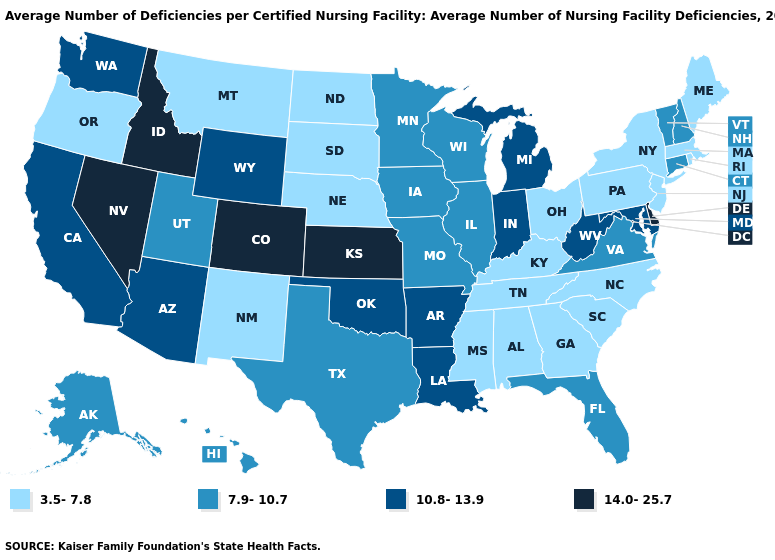Among the states that border Michigan , which have the lowest value?
Concise answer only. Ohio. Name the states that have a value in the range 3.5-7.8?
Be succinct. Alabama, Georgia, Kentucky, Maine, Massachusetts, Mississippi, Montana, Nebraska, New Jersey, New Mexico, New York, North Carolina, North Dakota, Ohio, Oregon, Pennsylvania, Rhode Island, South Carolina, South Dakota, Tennessee. Name the states that have a value in the range 10.8-13.9?
Short answer required. Arizona, Arkansas, California, Indiana, Louisiana, Maryland, Michigan, Oklahoma, Washington, West Virginia, Wyoming. What is the value of Colorado?
Answer briefly. 14.0-25.7. Name the states that have a value in the range 10.8-13.9?
Write a very short answer. Arizona, Arkansas, California, Indiana, Louisiana, Maryland, Michigan, Oklahoma, Washington, West Virginia, Wyoming. Name the states that have a value in the range 3.5-7.8?
Answer briefly. Alabama, Georgia, Kentucky, Maine, Massachusetts, Mississippi, Montana, Nebraska, New Jersey, New Mexico, New York, North Carolina, North Dakota, Ohio, Oregon, Pennsylvania, Rhode Island, South Carolina, South Dakota, Tennessee. Among the states that border Missouri , which have the lowest value?
Give a very brief answer. Kentucky, Nebraska, Tennessee. What is the value of Wyoming?
Answer briefly. 10.8-13.9. Which states have the lowest value in the Northeast?
Concise answer only. Maine, Massachusetts, New Jersey, New York, Pennsylvania, Rhode Island. Among the states that border Arkansas , which have the highest value?
Quick response, please. Louisiana, Oklahoma. Is the legend a continuous bar?
Be succinct. No. Among the states that border Colorado , does Nebraska have the lowest value?
Write a very short answer. Yes. Does Kansas have the highest value in the MidWest?
Short answer required. Yes. Does Delaware have the highest value in the South?
Keep it brief. Yes. Name the states that have a value in the range 10.8-13.9?
Write a very short answer. Arizona, Arkansas, California, Indiana, Louisiana, Maryland, Michigan, Oklahoma, Washington, West Virginia, Wyoming. 